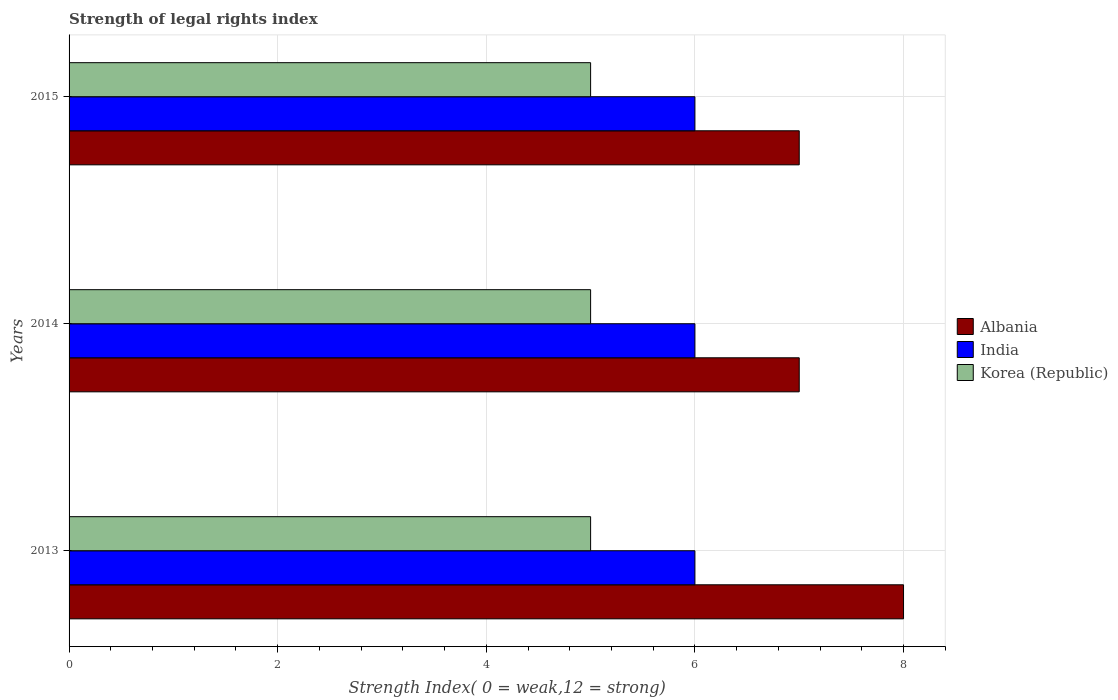Are the number of bars per tick equal to the number of legend labels?
Offer a very short reply. Yes. How many bars are there on the 2nd tick from the bottom?
Offer a terse response. 3. In how many cases, is the number of bars for a given year not equal to the number of legend labels?
Your response must be concise. 0. What is the strength index in India in 2014?
Your answer should be compact. 6. Across all years, what is the maximum strength index in Albania?
Provide a succinct answer. 8. In which year was the strength index in India maximum?
Provide a succinct answer. 2013. What is the total strength index in Albania in the graph?
Make the answer very short. 22. What is the difference between the strength index in India in 2013 and the strength index in Korea (Republic) in 2015?
Your response must be concise. 1. What is the average strength index in Korea (Republic) per year?
Offer a very short reply. 5. In the year 2014, what is the difference between the strength index in Korea (Republic) and strength index in Albania?
Provide a short and direct response. -2. What is the ratio of the strength index in India in 2013 to that in 2015?
Ensure brevity in your answer.  1. Is the strength index in India in 2013 less than that in 2014?
Keep it short and to the point. No. What is the difference between the highest and the second highest strength index in India?
Your answer should be very brief. 0. What does the 2nd bar from the top in 2013 represents?
Keep it short and to the point. India. Is it the case that in every year, the sum of the strength index in Albania and strength index in India is greater than the strength index in Korea (Republic)?
Your answer should be very brief. Yes. How many bars are there?
Give a very brief answer. 9. How many years are there in the graph?
Keep it short and to the point. 3. Are the values on the major ticks of X-axis written in scientific E-notation?
Your answer should be compact. No. Does the graph contain grids?
Offer a very short reply. Yes. What is the title of the graph?
Your answer should be very brief. Strength of legal rights index. What is the label or title of the X-axis?
Ensure brevity in your answer.  Strength Index( 0 = weak,12 = strong). What is the label or title of the Y-axis?
Provide a succinct answer. Years. What is the Strength Index( 0 = weak,12 = strong) in Albania in 2014?
Ensure brevity in your answer.  7. What is the Strength Index( 0 = weak,12 = strong) in Albania in 2015?
Your response must be concise. 7. Across all years, what is the maximum Strength Index( 0 = weak,12 = strong) of Albania?
Ensure brevity in your answer.  8. Across all years, what is the maximum Strength Index( 0 = weak,12 = strong) of Korea (Republic)?
Give a very brief answer. 5. Across all years, what is the minimum Strength Index( 0 = weak,12 = strong) of India?
Your answer should be very brief. 6. Across all years, what is the minimum Strength Index( 0 = weak,12 = strong) of Korea (Republic)?
Offer a very short reply. 5. What is the total Strength Index( 0 = weak,12 = strong) of Korea (Republic) in the graph?
Your response must be concise. 15. What is the difference between the Strength Index( 0 = weak,12 = strong) in Albania in 2013 and that in 2015?
Provide a short and direct response. 1. What is the difference between the Strength Index( 0 = weak,12 = strong) of Albania in 2013 and the Strength Index( 0 = weak,12 = strong) of India in 2014?
Ensure brevity in your answer.  2. What is the difference between the Strength Index( 0 = weak,12 = strong) of Albania in 2013 and the Strength Index( 0 = weak,12 = strong) of Korea (Republic) in 2014?
Keep it short and to the point. 3. What is the difference between the Strength Index( 0 = weak,12 = strong) in India in 2013 and the Strength Index( 0 = weak,12 = strong) in Korea (Republic) in 2014?
Provide a succinct answer. 1. What is the difference between the Strength Index( 0 = weak,12 = strong) of Albania in 2014 and the Strength Index( 0 = weak,12 = strong) of India in 2015?
Provide a short and direct response. 1. What is the difference between the Strength Index( 0 = weak,12 = strong) in Albania in 2014 and the Strength Index( 0 = weak,12 = strong) in Korea (Republic) in 2015?
Ensure brevity in your answer.  2. What is the average Strength Index( 0 = weak,12 = strong) in Albania per year?
Provide a succinct answer. 7.33. In the year 2013, what is the difference between the Strength Index( 0 = weak,12 = strong) in Albania and Strength Index( 0 = weak,12 = strong) in Korea (Republic)?
Make the answer very short. 3. In the year 2015, what is the difference between the Strength Index( 0 = weak,12 = strong) in Albania and Strength Index( 0 = weak,12 = strong) in Korea (Republic)?
Provide a succinct answer. 2. In the year 2015, what is the difference between the Strength Index( 0 = weak,12 = strong) of India and Strength Index( 0 = weak,12 = strong) of Korea (Republic)?
Provide a short and direct response. 1. What is the ratio of the Strength Index( 0 = weak,12 = strong) of Korea (Republic) in 2013 to that in 2014?
Provide a short and direct response. 1. What is the ratio of the Strength Index( 0 = weak,12 = strong) of Albania in 2013 to that in 2015?
Provide a short and direct response. 1.14. What is the ratio of the Strength Index( 0 = weak,12 = strong) of India in 2013 to that in 2015?
Ensure brevity in your answer.  1. What is the ratio of the Strength Index( 0 = weak,12 = strong) in Korea (Republic) in 2013 to that in 2015?
Keep it short and to the point. 1. What is the difference between the highest and the second highest Strength Index( 0 = weak,12 = strong) of Korea (Republic)?
Offer a very short reply. 0. What is the difference between the highest and the lowest Strength Index( 0 = weak,12 = strong) in Albania?
Your answer should be compact. 1. What is the difference between the highest and the lowest Strength Index( 0 = weak,12 = strong) in India?
Offer a terse response. 0. What is the difference between the highest and the lowest Strength Index( 0 = weak,12 = strong) in Korea (Republic)?
Provide a succinct answer. 0. 